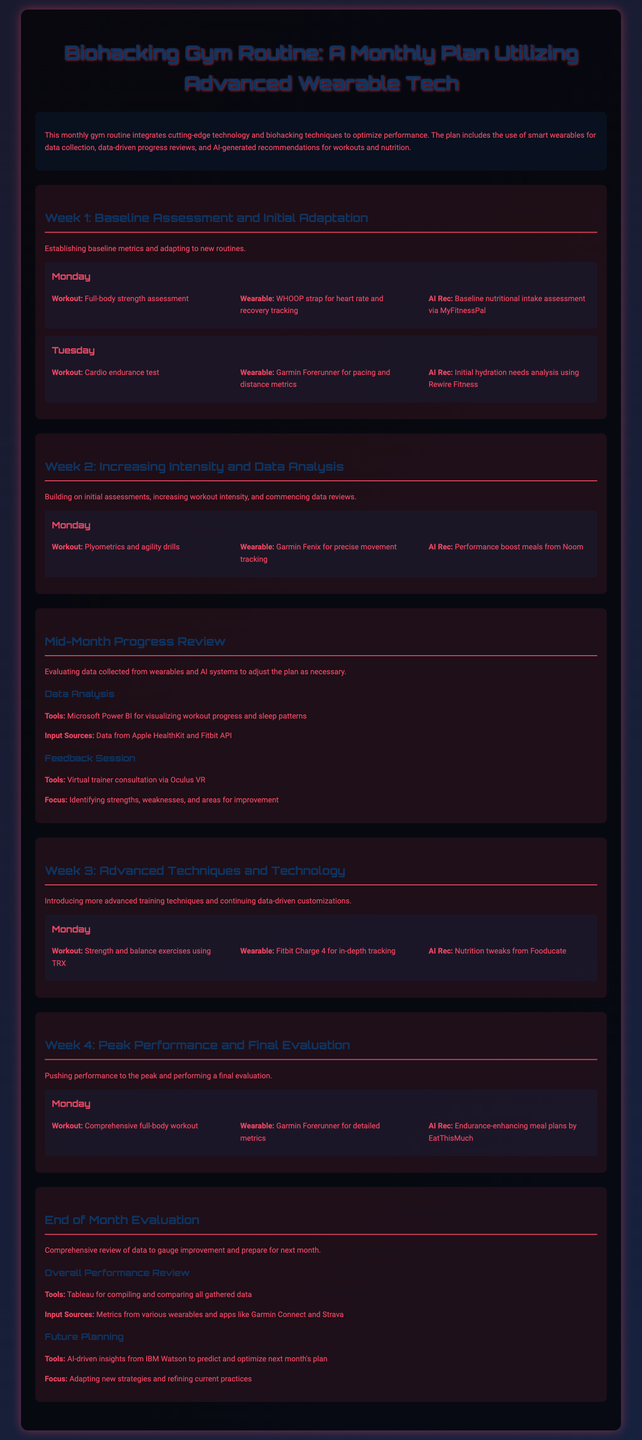What is the main purpose of the gym routine? The gym routine's main purpose is to optimize performance using advanced wearable tech and biohacking techniques.
Answer: Optimize performance Which wearable is used for heart rate and recovery tracking? The wearable used for heart rate and recovery tracking is the WHOOP strap.
Answer: WHOOP strap What is the focus of the Mid-Month Progress Review? The focus is on evaluating data collected from wearables and AI systems to adjust the plan as necessary.
Answer: Evaluating data collected How many weeks are detailed in the monthly plan? The monthly plan outlines four weeks of workouts and assessments.
Answer: Four weeks What tool is used for visualizing workout progress? The tool used for visualizing workout progress is Microsoft Power BI.
Answer: Microsoft Power BI Which week is dedicated to Peak Performance and Final Evaluation? The week dedicated to Peak Performance and Final Evaluation is Week 4.
Answer: Week 4 What type of exercises are introduced in Week 3? Strength and balance exercises using TRX are introduced in Week 3.
Answer: Strength and balance exercises Which AI tool is mentioned for predicting next month's plan? The AI tool mentioned for predicting next month's plan is IBM Watson.
Answer: IBM Watson What is the recommended meal plan provider for endurance enhancement? The recommended meal plan provider for endurance enhancement is EatThisMuch.
Answer: EatThisMuch What type of review occurs at the end of the month? A comprehensive review of data to gauge improvement occurs at the end of the month.
Answer: Comprehensive review of data 